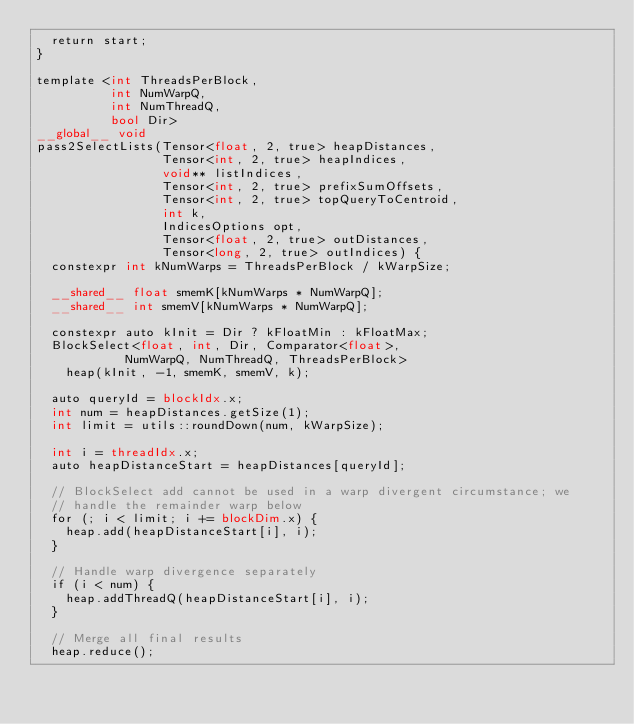Convert code to text. <code><loc_0><loc_0><loc_500><loc_500><_Cuda_>  return start;
}

template <int ThreadsPerBlock,
          int NumWarpQ,
          int NumThreadQ,
          bool Dir>
__global__ void
pass2SelectLists(Tensor<float, 2, true> heapDistances,
                 Tensor<int, 2, true> heapIndices,
                 void** listIndices,
                 Tensor<int, 2, true> prefixSumOffsets,
                 Tensor<int, 2, true> topQueryToCentroid,
                 int k,
                 IndicesOptions opt,
                 Tensor<float, 2, true> outDistances,
                 Tensor<long, 2, true> outIndices) {
  constexpr int kNumWarps = ThreadsPerBlock / kWarpSize;

  __shared__ float smemK[kNumWarps * NumWarpQ];
  __shared__ int smemV[kNumWarps * NumWarpQ];

  constexpr auto kInit = Dir ? kFloatMin : kFloatMax;
  BlockSelect<float, int, Dir, Comparator<float>,
            NumWarpQ, NumThreadQ, ThreadsPerBlock>
    heap(kInit, -1, smemK, smemV, k);

  auto queryId = blockIdx.x;
  int num = heapDistances.getSize(1);
  int limit = utils::roundDown(num, kWarpSize);

  int i = threadIdx.x;
  auto heapDistanceStart = heapDistances[queryId];

  // BlockSelect add cannot be used in a warp divergent circumstance; we
  // handle the remainder warp below
  for (; i < limit; i += blockDim.x) {
    heap.add(heapDistanceStart[i], i);
  }

  // Handle warp divergence separately
  if (i < num) {
    heap.addThreadQ(heapDistanceStart[i], i);
  }

  // Merge all final results
  heap.reduce();
</code> 